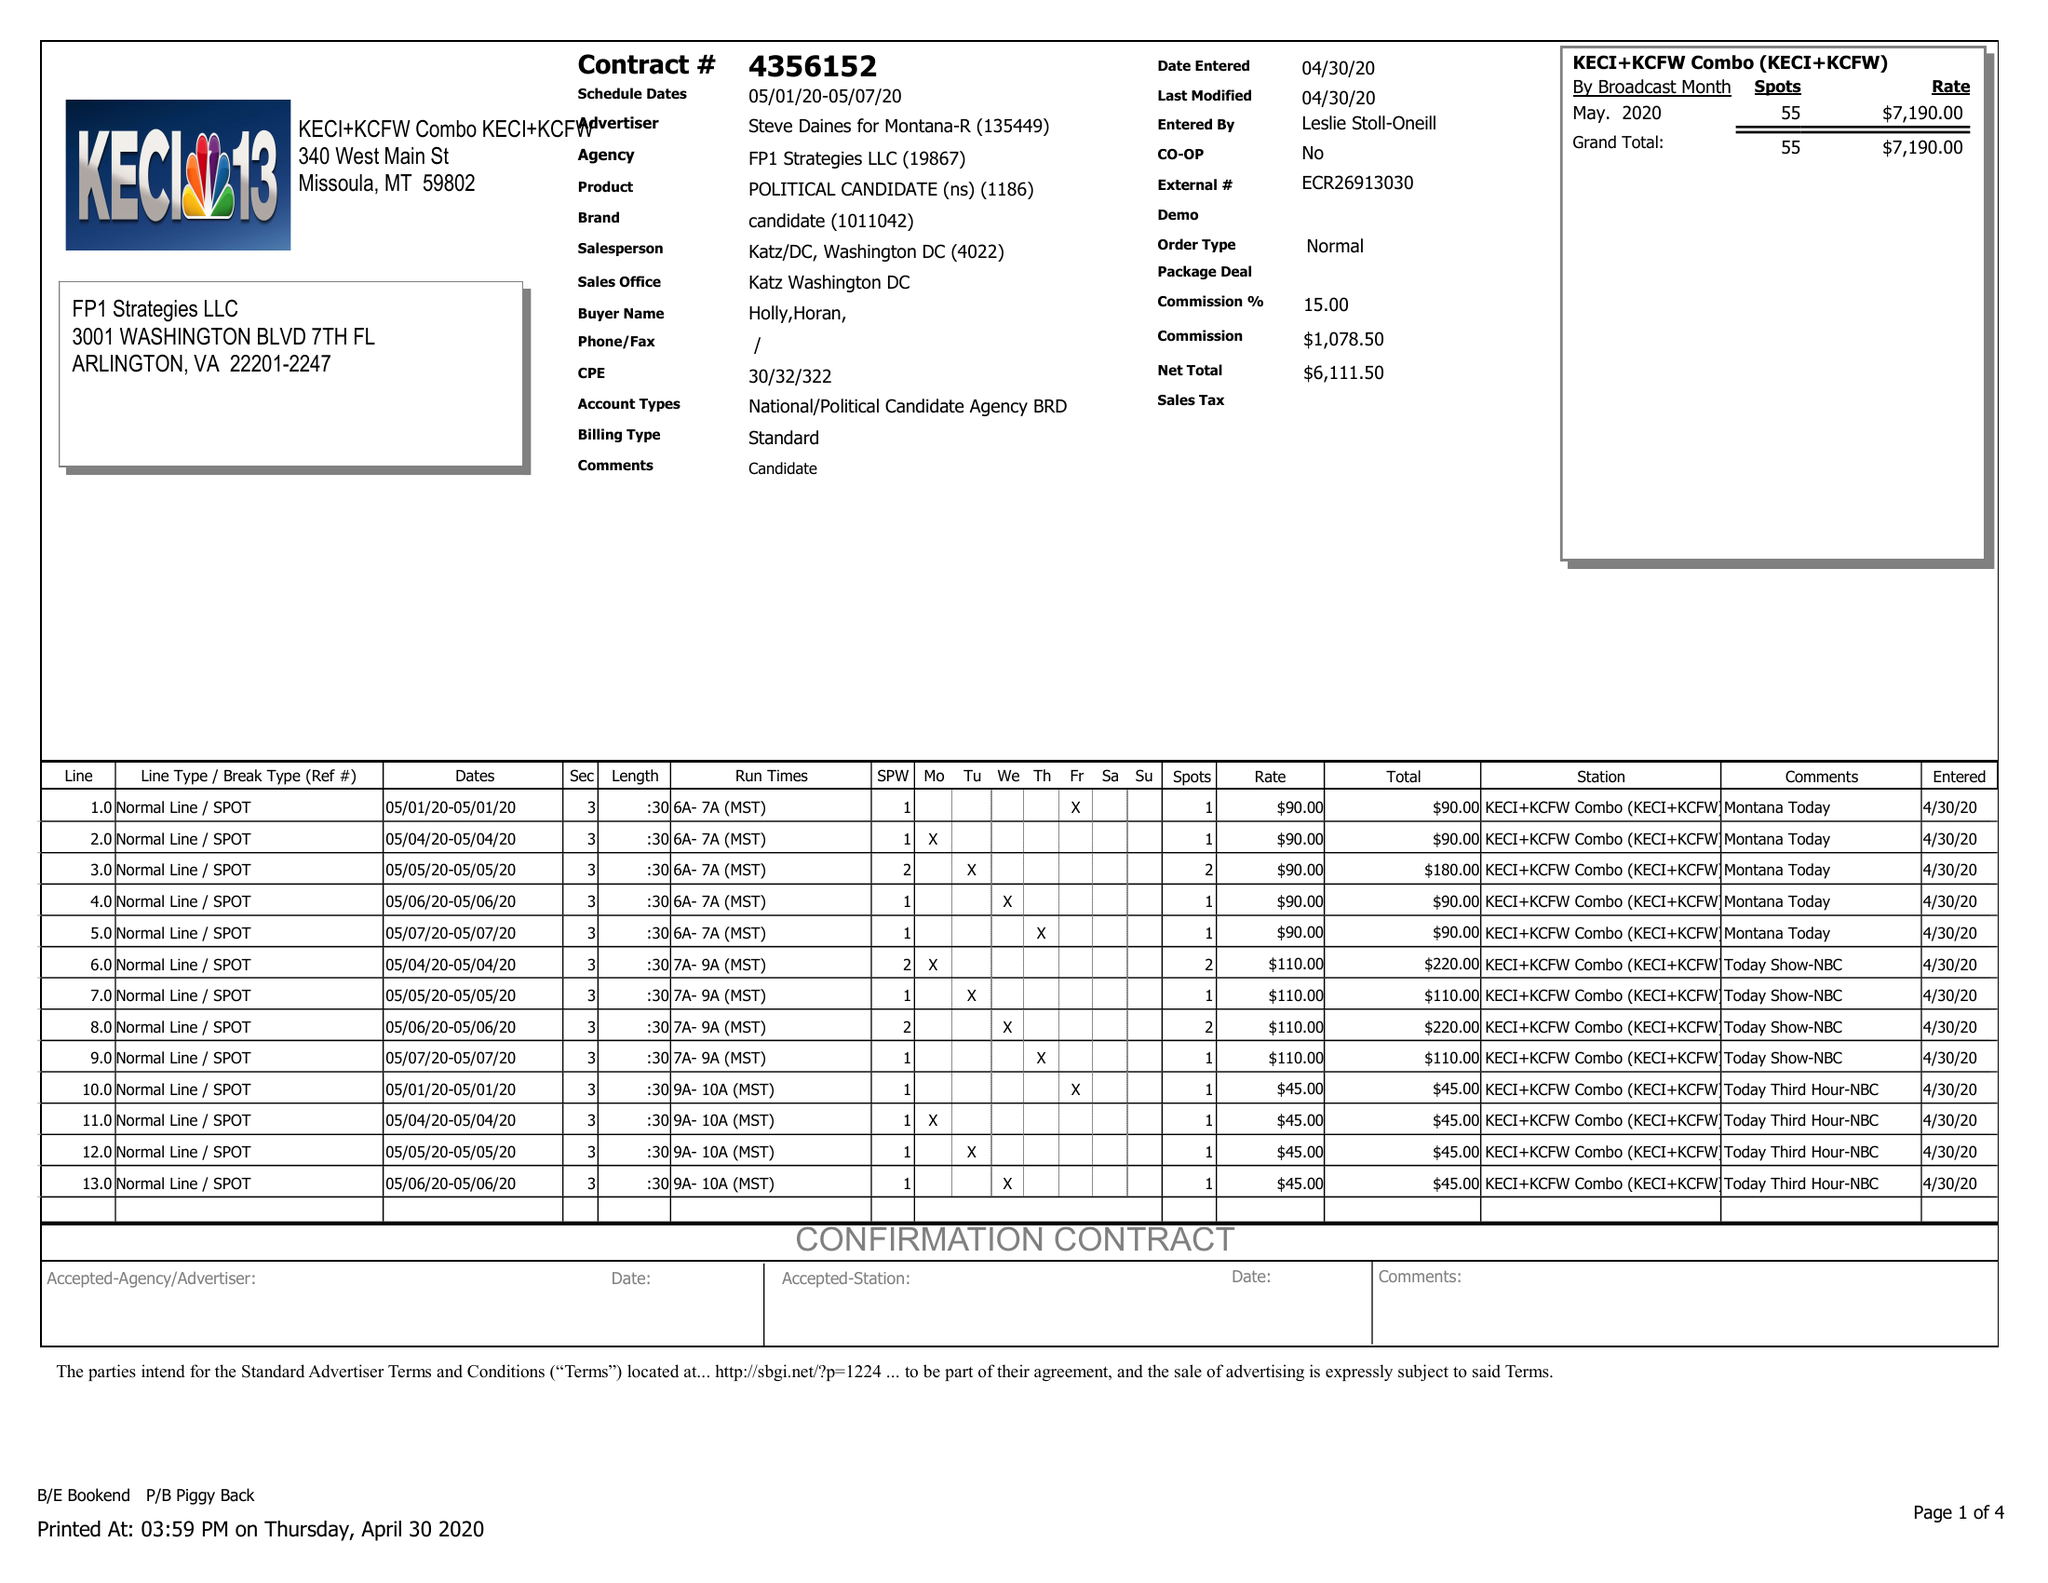What is the value for the flight_to?
Answer the question using a single word or phrase. 05/07/20 